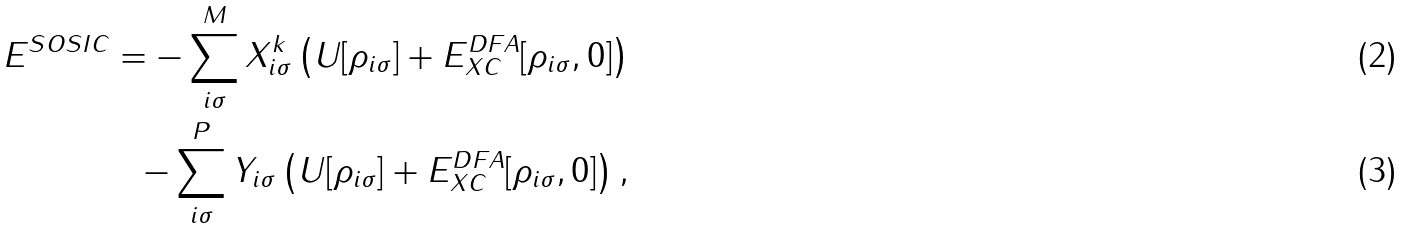Convert formula to latex. <formula><loc_0><loc_0><loc_500><loc_500>E ^ { S O S I C } = - \sum _ { i \sigma } ^ { M } X _ { i \sigma } ^ { k } \left ( U [ \rho _ { i \sigma } ] + E _ { X C } ^ { D F A } [ \rho _ { i \sigma } , 0 ] \right ) \\ - \sum _ { i \sigma } ^ { P } Y _ { i \sigma } \left ( U [ \rho _ { i \sigma } ] + E _ { X C } ^ { D F A } [ \rho _ { i \sigma } , 0 ] \right ) ,</formula> 